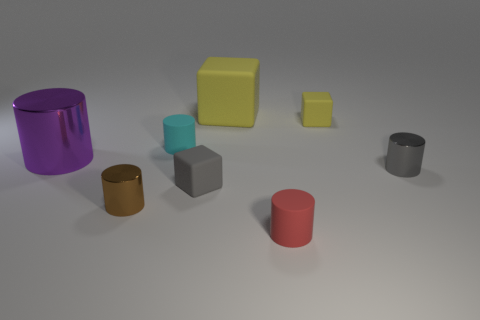Add 1 big cylinders. How many objects exist? 9 Subtract all tiny blocks. How many blocks are left? 1 Add 6 big metal cylinders. How many big metal cylinders are left? 7 Add 3 cyan rubber cylinders. How many cyan rubber cylinders exist? 4 Subtract all red cylinders. How many cylinders are left? 4 Subtract 0 blue balls. How many objects are left? 8 Subtract all cylinders. How many objects are left? 3 Subtract 2 blocks. How many blocks are left? 1 Subtract all gray cylinders. Subtract all brown balls. How many cylinders are left? 4 Subtract all cyan cylinders. How many yellow blocks are left? 2 